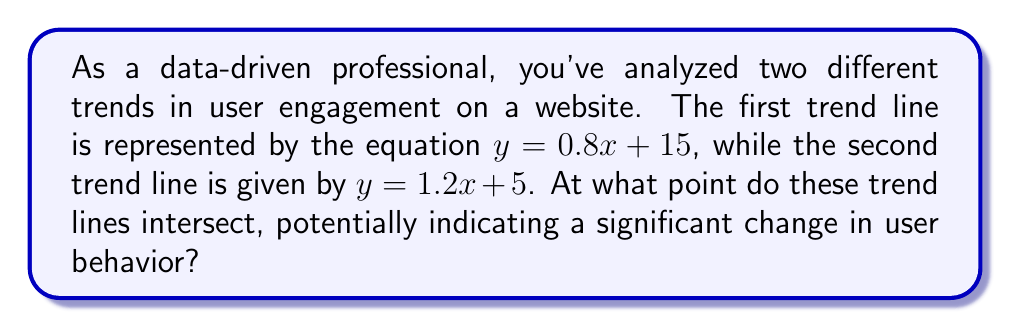Show me your answer to this math problem. To find the intersection point of two lines, we need to solve the system of equations formed by the two line equations:

$$\begin{cases}
y = 0.8x + 15 \\
y = 1.2x + 5
\end{cases}$$

At the intersection point, the y-values are equal, so we can set the right sides of the equations equal to each other:

$$0.8x + 15 = 1.2x + 5$$

Now, let's solve for x:

1) Subtract 0.8x from both sides:
   $$15 = 0.4x + 5$$

2) Subtract 5 from both sides:
   $$10 = 0.4x$$

3) Divide both sides by 0.4:
   $$25 = x$$

Now that we have the x-coordinate, we can substitute it into either of the original equations to find the y-coordinate. Let's use the first equation:

$$\begin{align}
y &= 0.8(25) + 15 \\
y &= 20 + 15 \\
y &= 35
\end{align}$$

Therefore, the intersection point is (25, 35).

[asy]
import graph;
size(200);
xaxis("x", arrow=Arrow);
yaxis("y", arrow=Arrow);
real f(real x) {return 0.8x + 15;}
real g(real x) {return 1.2x + 5;}
draw(graph(f,0,35), blue);
draw(graph(g,0,35), red);
dot((25,35), green);
label("(25, 35)", (25,35), NE);
[/asy]
Answer: The trend lines intersect at the point (25, 35). 